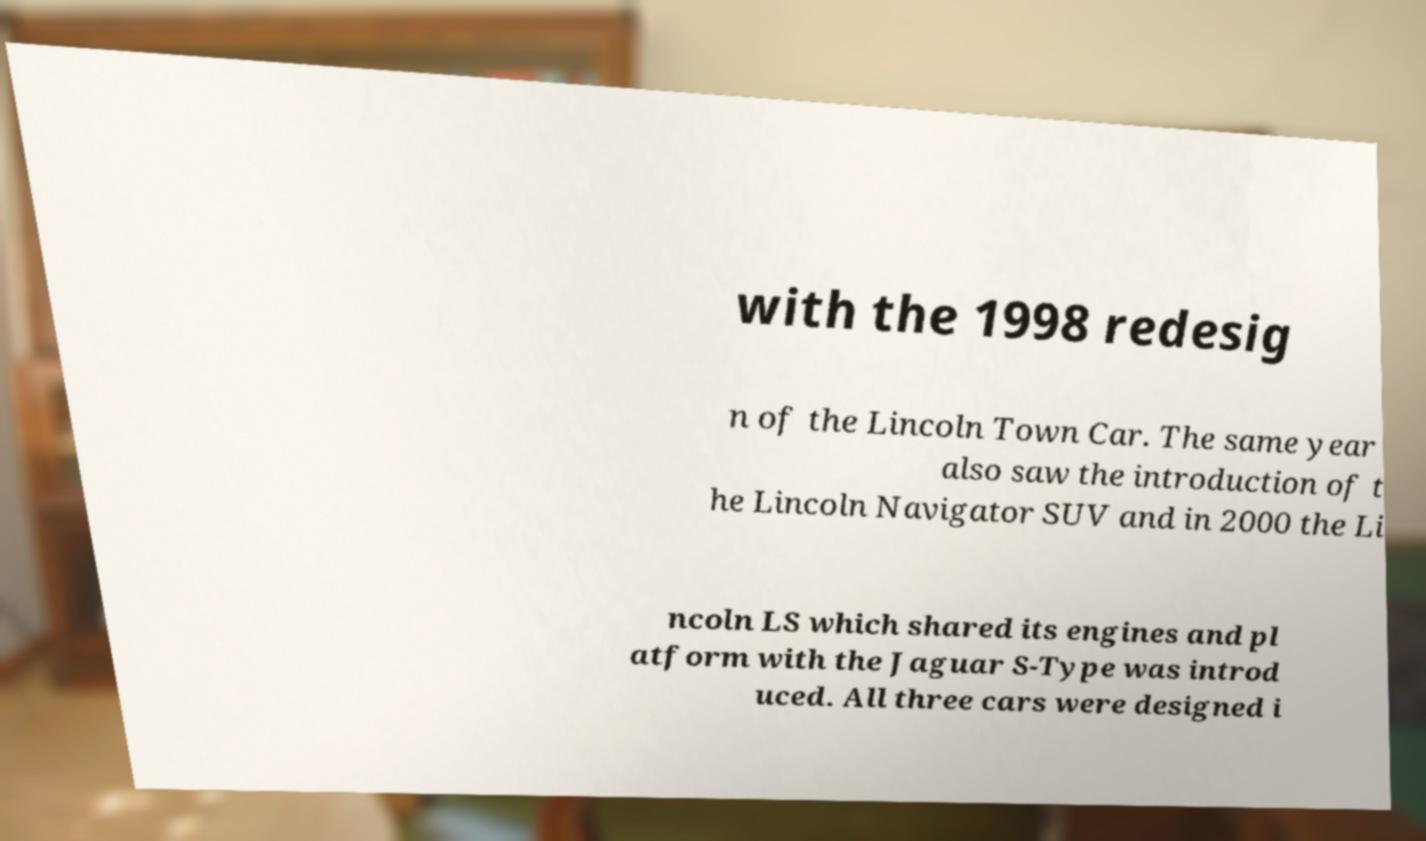Can you read and provide the text displayed in the image?This photo seems to have some interesting text. Can you extract and type it out for me? with the 1998 redesig n of the Lincoln Town Car. The same year also saw the introduction of t he Lincoln Navigator SUV and in 2000 the Li ncoln LS which shared its engines and pl atform with the Jaguar S-Type was introd uced. All three cars were designed i 